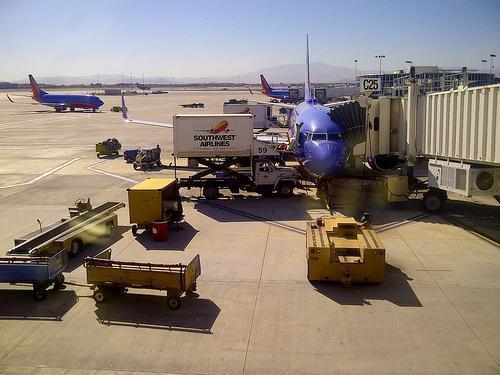How many airplanes are there?
Give a very brief answer. 3. How many planes are in the air?
Give a very brief answer. 0. 